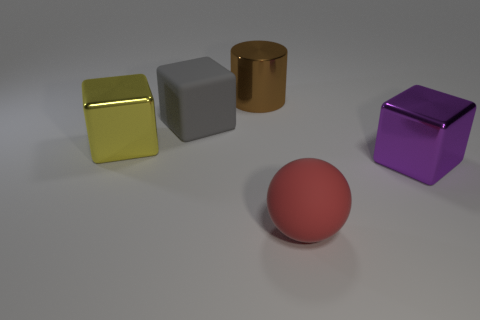Subtract all big gray rubber cubes. How many cubes are left? 2 Add 1 large blue metallic objects. How many objects exist? 6 Subtract all gray cubes. How many cubes are left? 2 Subtract 1 blocks. How many blocks are left? 2 Subtract all yellow balls. Subtract all gray cylinders. How many balls are left? 1 Add 5 big blue shiny things. How many big blue shiny things exist? 5 Subtract 0 cyan spheres. How many objects are left? 5 Subtract all blocks. How many objects are left? 2 Subtract all purple metallic blocks. Subtract all blue rubber cubes. How many objects are left? 4 Add 3 gray matte objects. How many gray matte objects are left? 4 